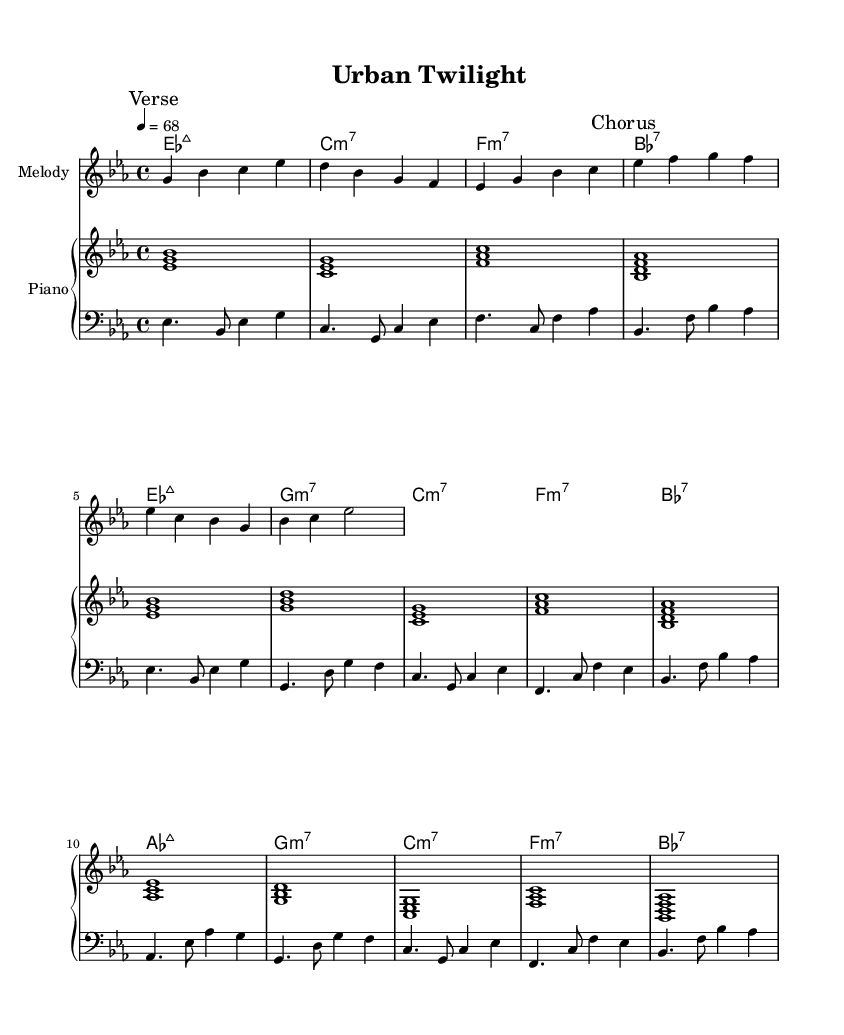What is the key signature of this music? The key signature shows two flats, indicating that the music is in the key of E flat major or C minor.
Answer: E flat major What is the time signature of this music? The time signature is 4/4, which is shown at the beginning of the sheet music and suggests a common meter with four beats per measure.
Answer: 4/4 What is the tempo marking for this piece? The tempo is indicated as "4 = 68," meaning there are 68 beats per minute, which is a moderate pace for the piece.
Answer: 68 How many measures are in the melody section? Counting the measures in the melody part, there are a total of 8 measures in the verse and 4 measures in the chorus; thus, the entire melody section comprises 12 measures.
Answer: 12 What is the first chord played in the piano part? The first chord indicated in the piano part is E flat major 7, which is the first chord for the introduction as shown on the chord names.
Answer: E flat major 7 How does the bass line change in the chorus? In the chorus, the bass line features a shift from E flat to A flat, marking a harmonic progression that begins with A flat major 7 and continues with G minor 7.
Answer: E flat to A flat Which jazz chord type is predominantly used in the chord progression? The dominant chord types used throughout the progression include major 7 and minor 7 chords, common in neo-soul and jazz-influenced music.
Answer: Major 7 and minor 7 